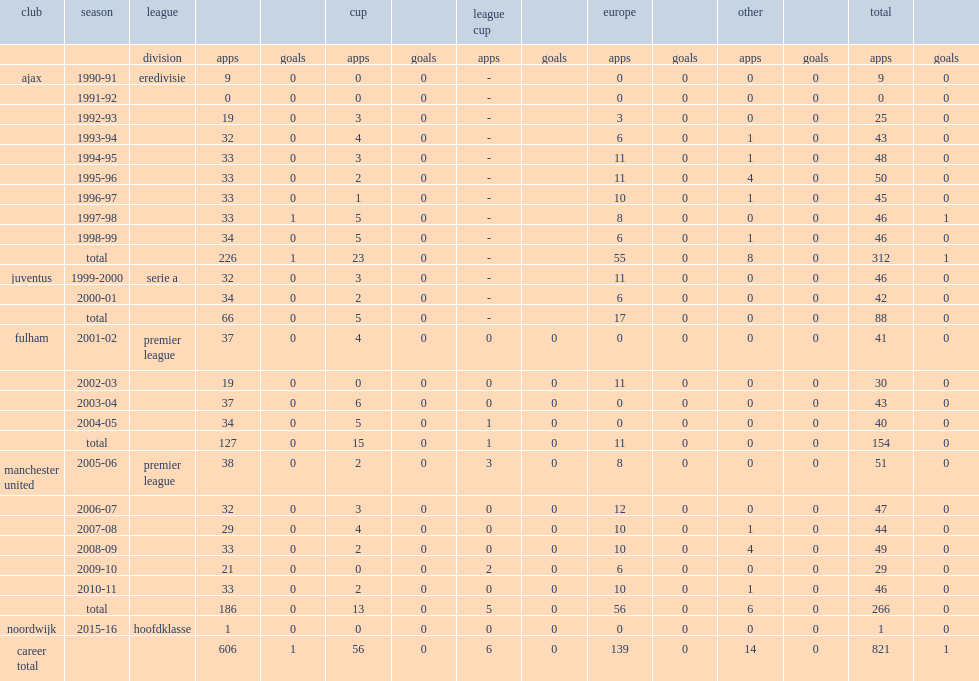Would you mind parsing the complete table? {'header': ['club', 'season', 'league', '', '', 'cup', '', 'league cup', '', 'europe', '', 'other', '', 'total', ''], 'rows': [['', '', 'division', 'apps', 'goals', 'apps', 'goals', 'apps', 'goals', 'apps', 'goals', 'apps', 'goals', 'apps', 'goals'], ['ajax', '1990-91', 'eredivisie', '9', '0', '0', '0', '-', '', '0', '0', '0', '0', '9', '0'], ['', '1991-92', '', '0', '0', '0', '0', '-', '', '0', '0', '0', '0', '0', '0'], ['', '1992-93', '', '19', '0', '3', '0', '-', '', '3', '0', '0', '0', '25', '0'], ['', '1993-94', '', '32', '0', '4', '0', '-', '', '6', '0', '1', '0', '43', '0'], ['', '1994-95', '', '33', '0', '3', '0', '-', '', '11', '0', '1', '0', '48', '0'], ['', '1995-96', '', '33', '0', '2', '0', '-', '', '11', '0', '4', '0', '50', '0'], ['', '1996-97', '', '33', '0', '1', '0', '-', '', '10', '0', '1', '0', '45', '0'], ['', '1997-98', '', '33', '1', '5', '0', '-', '', '8', '0', '0', '0', '46', '1'], ['', '1998-99', '', '34', '0', '5', '0', '-', '', '6', '0', '1', '0', '46', '0'], ['', 'total', '', '226', '1', '23', '0', '-', '', '55', '0', '8', '0', '312', '1'], ['juventus', '1999-2000', 'serie a', '32', '0', '3', '0', '-', '', '11', '0', '0', '0', '46', '0'], ['', '2000-01', '', '34', '0', '2', '0', '-', '', '6', '0', '0', '0', '42', '0'], ['', 'total', '', '66', '0', '5', '0', '-', '', '17', '0', '0', '0', '88', '0'], ['fulham', '2001-02', 'premier league', '37', '0', '4', '0', '0', '0', '0', '0', '0', '0', '41', '0'], ['', '2002-03', '', '19', '0', '0', '0', '0', '0', '11', '0', '0', '0', '30', '0'], ['', '2003-04', '', '37', '0', '6', '0', '0', '0', '0', '0', '0', '0', '43', '0'], ['', '2004-05', '', '34', '0', '5', '0', '1', '0', '0', '0', '0', '0', '40', '0'], ['', 'total', '', '127', '0', '15', '0', '1', '0', '11', '0', '0', '0', '154', '0'], ['manchester united', '2005-06', 'premier league', '38', '0', '2', '0', '3', '0', '8', '0', '0', '0', '51', '0'], ['', '2006-07', '', '32', '0', '3', '0', '0', '0', '12', '0', '0', '0', '47', '0'], ['', '2007-08', '', '29', '0', '4', '0', '0', '0', '10', '0', '1', '0', '44', '0'], ['', '2008-09', '', '33', '0', '2', '0', '0', '0', '10', '0', '4', '0', '49', '0'], ['', '2009-10', '', '21', '0', '0', '0', '2', '0', '6', '0', '0', '0', '29', '0'], ['', '2010-11', '', '33', '0', '2', '0', '0', '0', '10', '0', '1', '0', '46', '0'], ['', 'total', '', '186', '0', '13', '0', '5', '0', '56', '0', '6', '0', '266', '0'], ['noordwijk', '2015-16', 'hoofdklasse', '1', '0', '0', '0', '0', '0', '0', '0', '0', '0', '1', '0'], ['career total', '', '', '606', '1', '56', '0', '6', '0', '139', '0', '14', '0', '821', '1']]} What was the total number of league appearances made by edwin van for ajax? 226.0. 